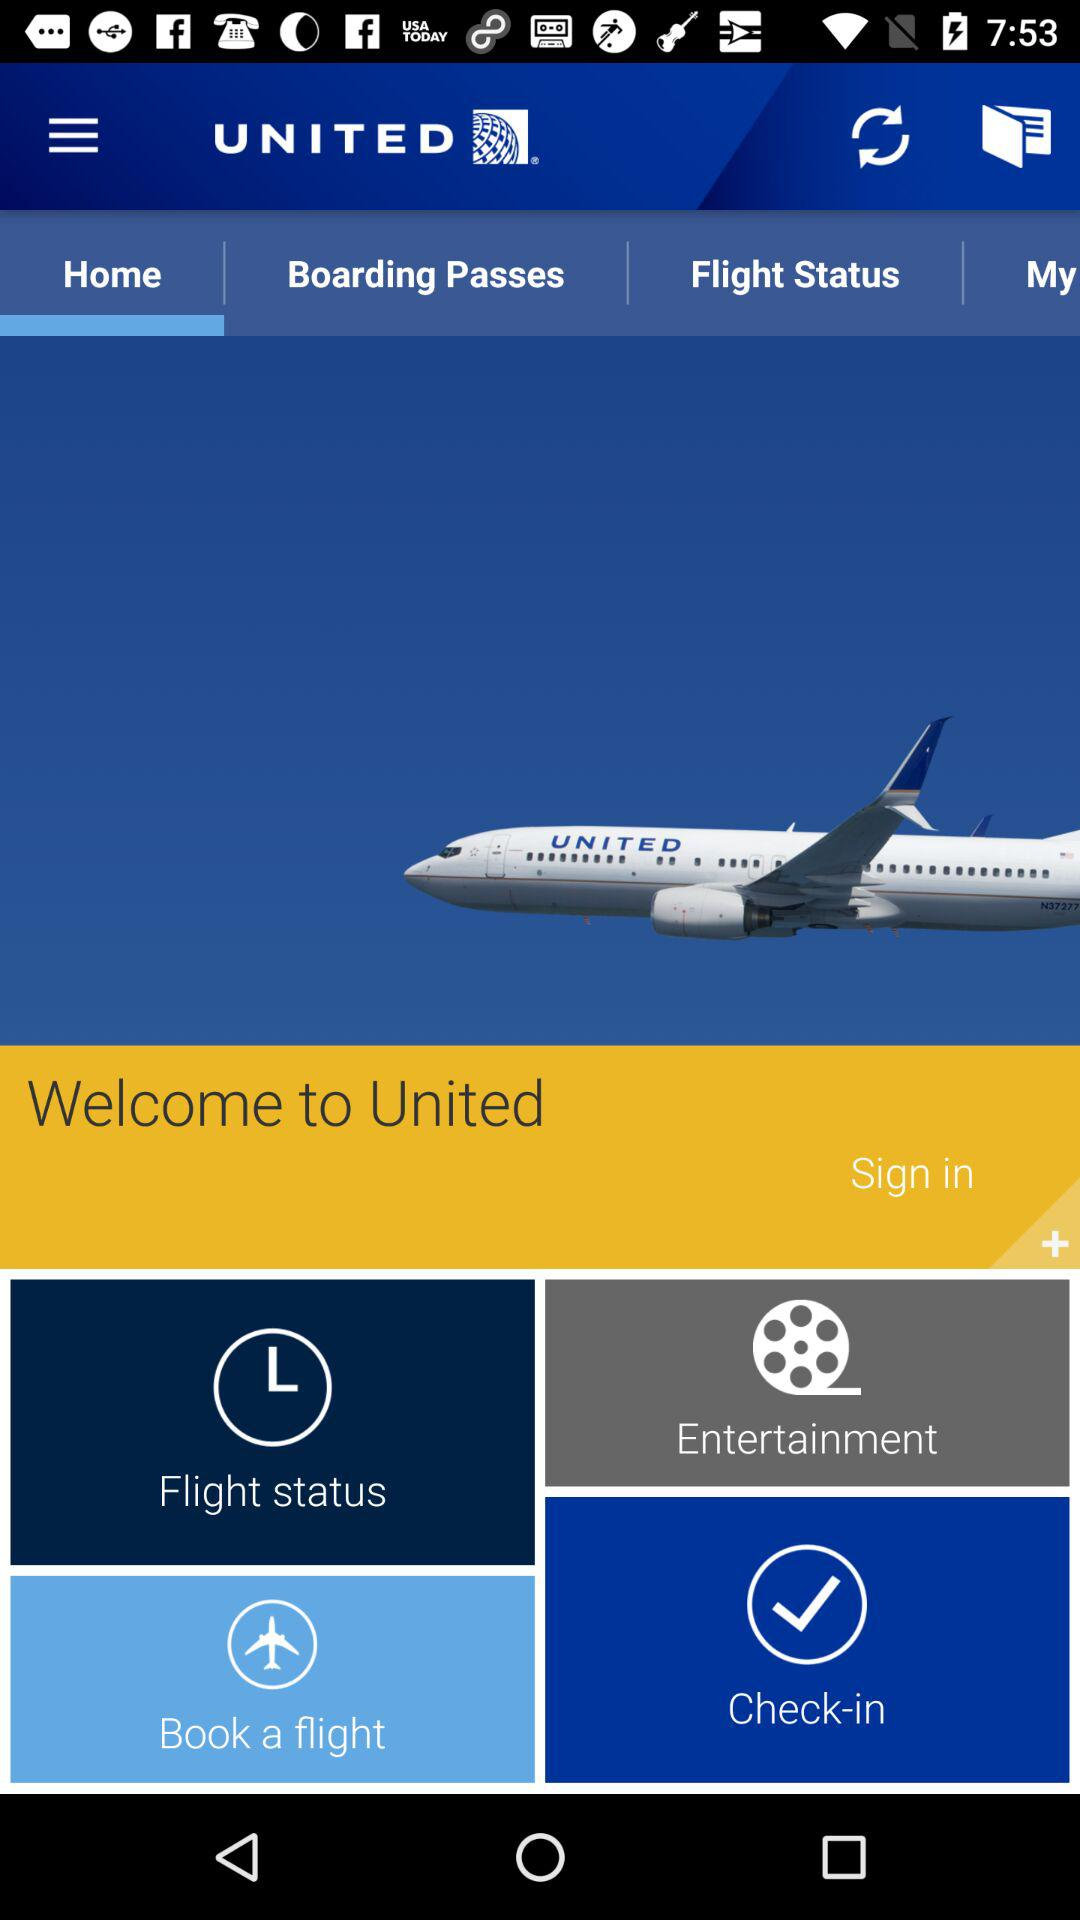What is the name of the application? The name of the application is "UNITED". 